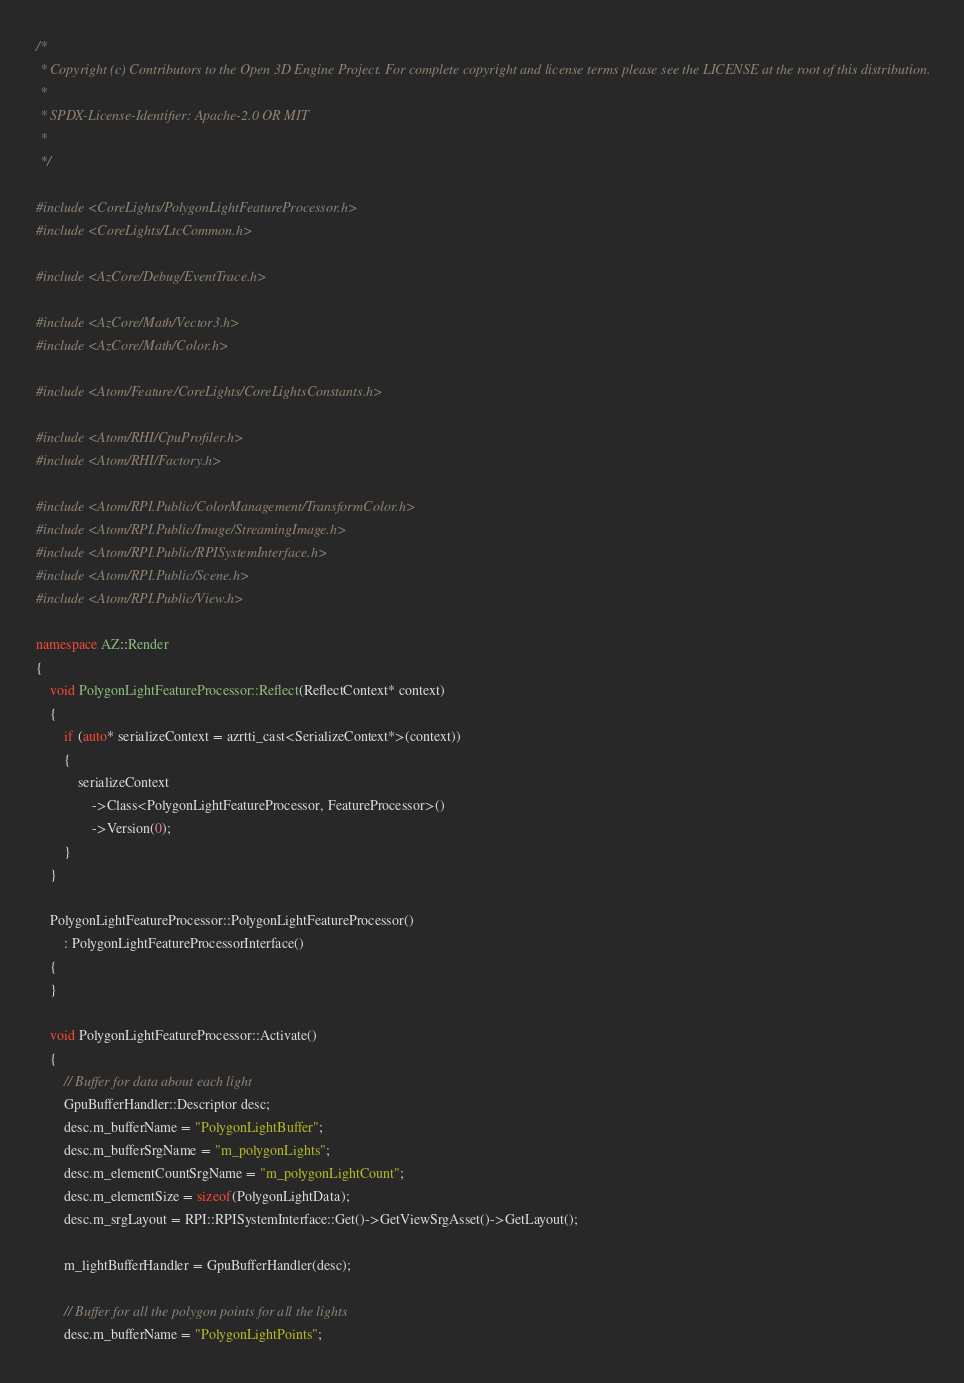Convert code to text. <code><loc_0><loc_0><loc_500><loc_500><_C++_>/*
 * Copyright (c) Contributors to the Open 3D Engine Project. For complete copyright and license terms please see the LICENSE at the root of this distribution.
 * 
 * SPDX-License-Identifier: Apache-2.0 OR MIT
 *
 */

#include <CoreLights/PolygonLightFeatureProcessor.h>
#include <CoreLights/LtcCommon.h>

#include <AzCore/Debug/EventTrace.h>

#include <AzCore/Math/Vector3.h>
#include <AzCore/Math/Color.h>

#include <Atom/Feature/CoreLights/CoreLightsConstants.h>

#include <Atom/RHI/CpuProfiler.h>
#include <Atom/RHI/Factory.h>

#include <Atom/RPI.Public/ColorManagement/TransformColor.h>
#include <Atom/RPI.Public/Image/StreamingImage.h>
#include <Atom/RPI.Public/RPISystemInterface.h>
#include <Atom/RPI.Public/Scene.h>
#include <Atom/RPI.Public/View.h>

namespace AZ::Render
{
    void PolygonLightFeatureProcessor::Reflect(ReflectContext* context)
    {
        if (auto* serializeContext = azrtti_cast<SerializeContext*>(context))
        {
            serializeContext
                ->Class<PolygonLightFeatureProcessor, FeatureProcessor>()
                ->Version(0);
        }
    }

    PolygonLightFeatureProcessor::PolygonLightFeatureProcessor()
        : PolygonLightFeatureProcessorInterface()
    {
    }

    void PolygonLightFeatureProcessor::Activate()
    {
        // Buffer for data about each light
        GpuBufferHandler::Descriptor desc;
        desc.m_bufferName = "PolygonLightBuffer";
        desc.m_bufferSrgName = "m_polygonLights";
        desc.m_elementCountSrgName = "m_polygonLightCount";
        desc.m_elementSize = sizeof(PolygonLightData);
        desc.m_srgLayout = RPI::RPISystemInterface::Get()->GetViewSrgAsset()->GetLayout();

        m_lightBufferHandler = GpuBufferHandler(desc);

        // Buffer for all the polygon points for all the lights
        desc.m_bufferName = "PolygonLightPoints";</code> 